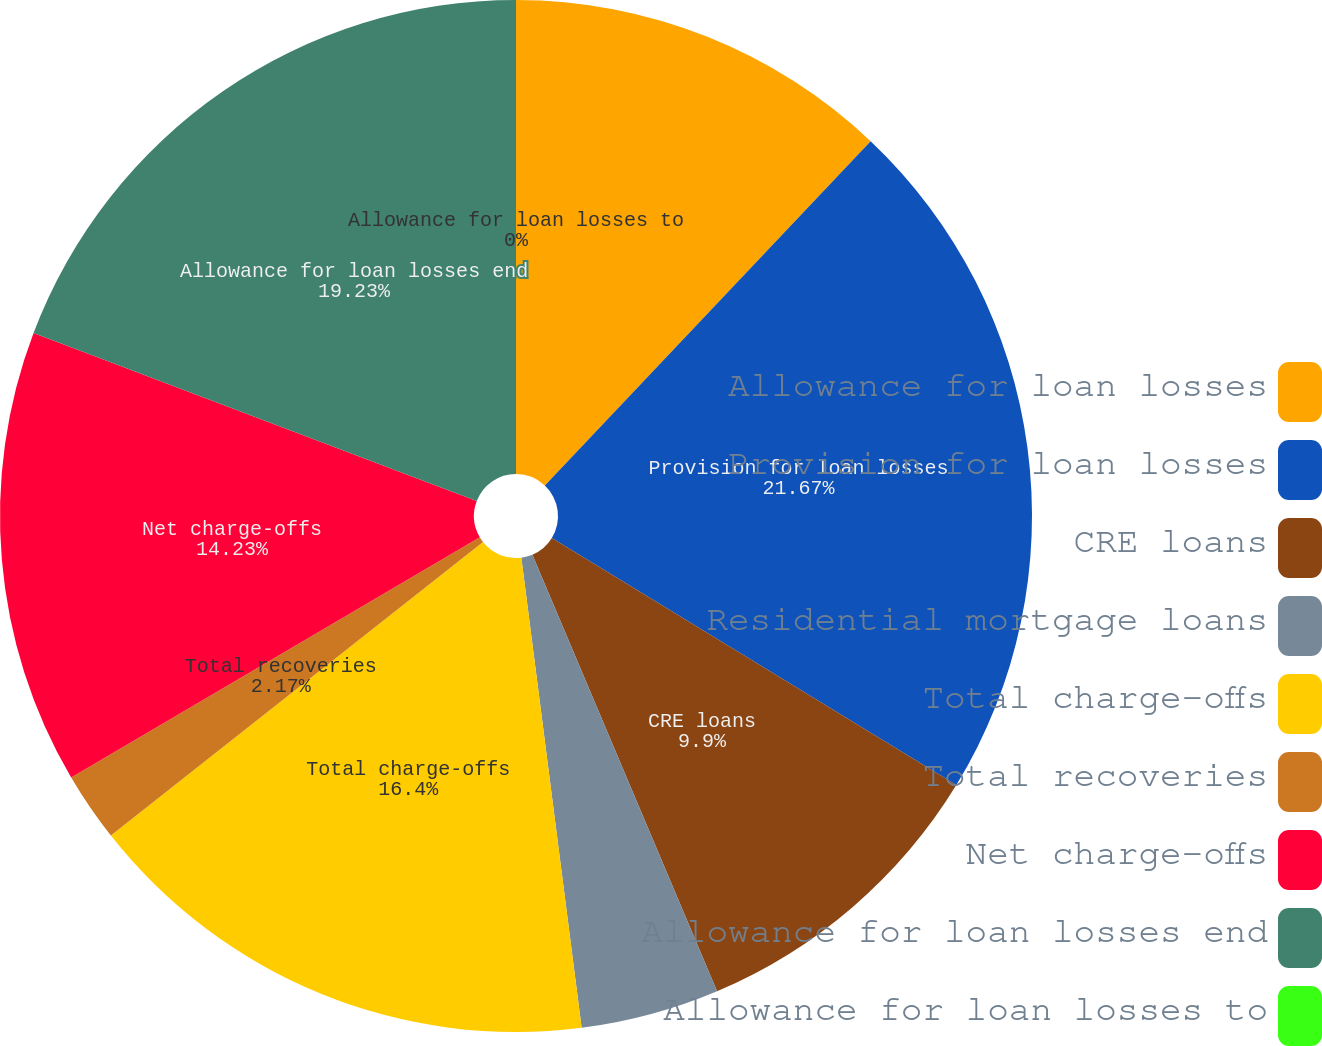Convert chart to OTSL. <chart><loc_0><loc_0><loc_500><loc_500><pie_chart><fcel>Allowance for loan losses<fcel>Provision for loan losses<fcel>CRE loans<fcel>Residential mortgage loans<fcel>Total charge-offs<fcel>Total recoveries<fcel>Net charge-offs<fcel>Allowance for loan losses end<fcel>Allowance for loan losses to<nl><fcel>12.06%<fcel>21.67%<fcel>9.9%<fcel>4.34%<fcel>16.4%<fcel>2.17%<fcel>14.23%<fcel>19.23%<fcel>0.0%<nl></chart> 